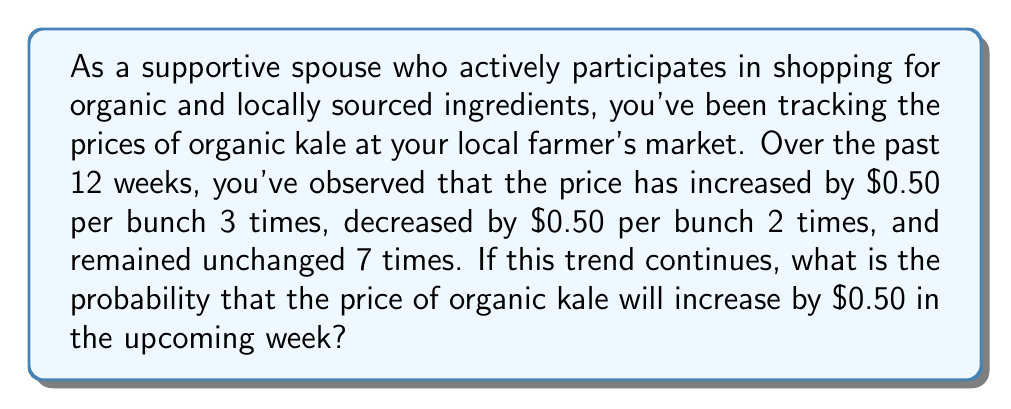Provide a solution to this math problem. To solve this problem, we need to use the concept of relative frequency as an estimate of probability. Here's a step-by-step explanation:

1. First, let's identify the total number of observations:
   $$ \text{Total observations} = 3 + 2 + 7 = 12 $$

2. Now, let's count the number of times the price increased:
   $$ \text{Number of price increases} = 3 $$

3. To calculate the probability, we use the formula:
   $$ P(\text{event}) = \frac{\text{Number of favorable outcomes}}{\text{Total number of possible outcomes}} $$

4. In this case:
   $$ P(\text{price increase}) = \frac{\text{Number of price increases}}{\text{Total observations}} $$

5. Substituting the values:
   $$ P(\text{price increase}) = \frac{3}{12} = \frac{1}{4} = 0.25 $$

Therefore, based on the observed trend, the probability that the price of organic kale will increase by $0.50 in the upcoming week is 0.25 or 25%.
Answer: $\frac{1}{4}$ or 0.25 or 25% 